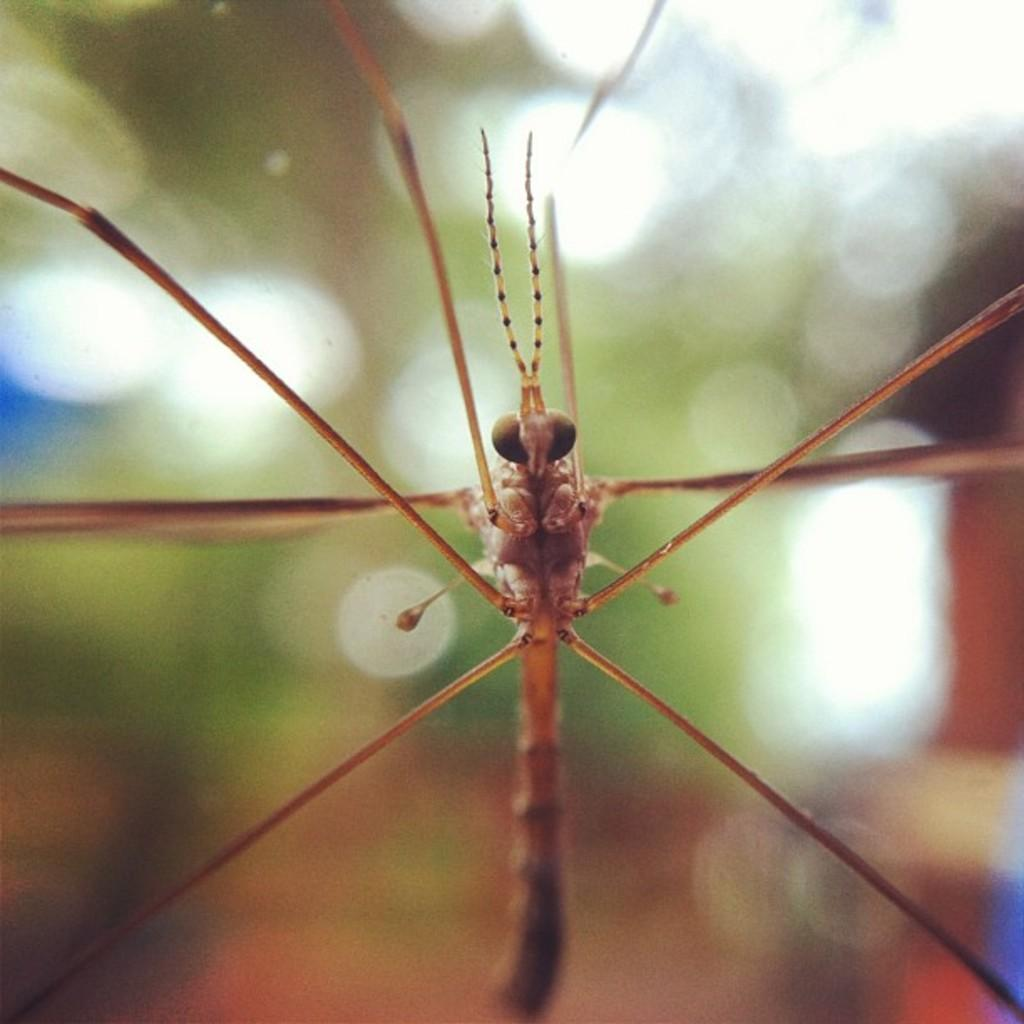What type of insect is present in the image? There is a fly in the image. How many children are playing with the current in the image? There are no children or current present in the image; it only features a fly. 